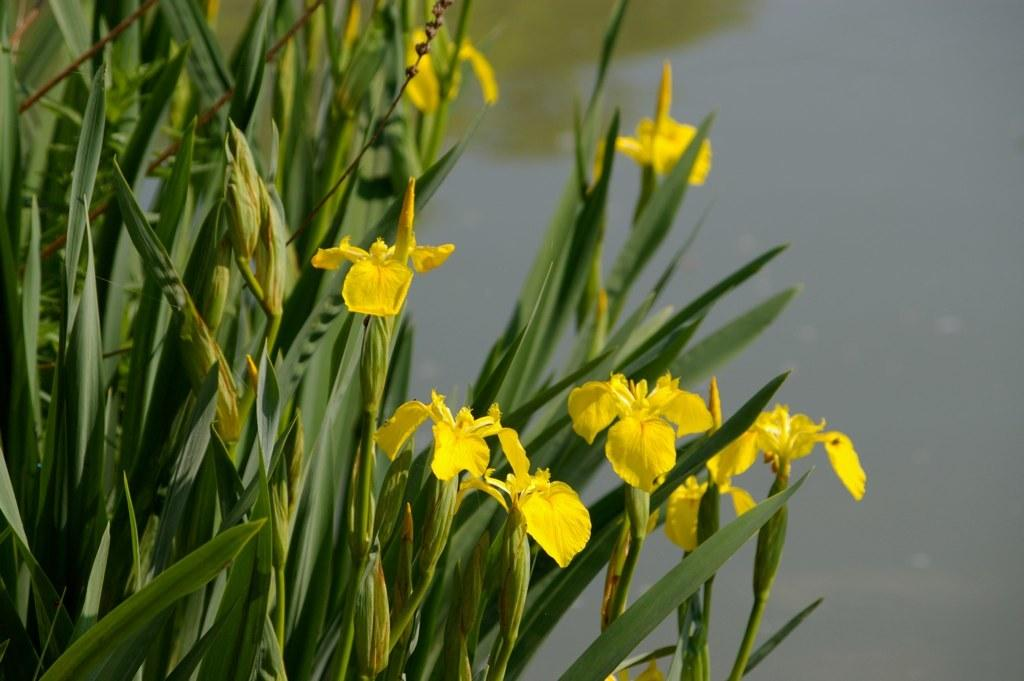What is the main subject of the image? There are planets in the center of the image. What other elements can be seen in the image? There are yellow flowers in the image. What can be seen in the background of the image? There is water visible in the background of the image. What type of education is being provided in the image? There is no indication of education in the image; it features planets and yellow flowers with water in the background. How many kittens are visible in the image? There are no kittens present in the image. 